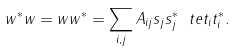<formula> <loc_0><loc_0><loc_500><loc_500>w ^ { * } w = w w ^ { * } = \sum _ { i , j } A _ { i j } s _ { j } s _ { j } ^ { * } \ t e t _ { i } t _ { i } ^ { * } .</formula> 